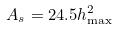Convert formula to latex. <formula><loc_0><loc_0><loc_500><loc_500>A _ { s } = 2 4 . 5 h _ { \max } ^ { 2 }</formula> 